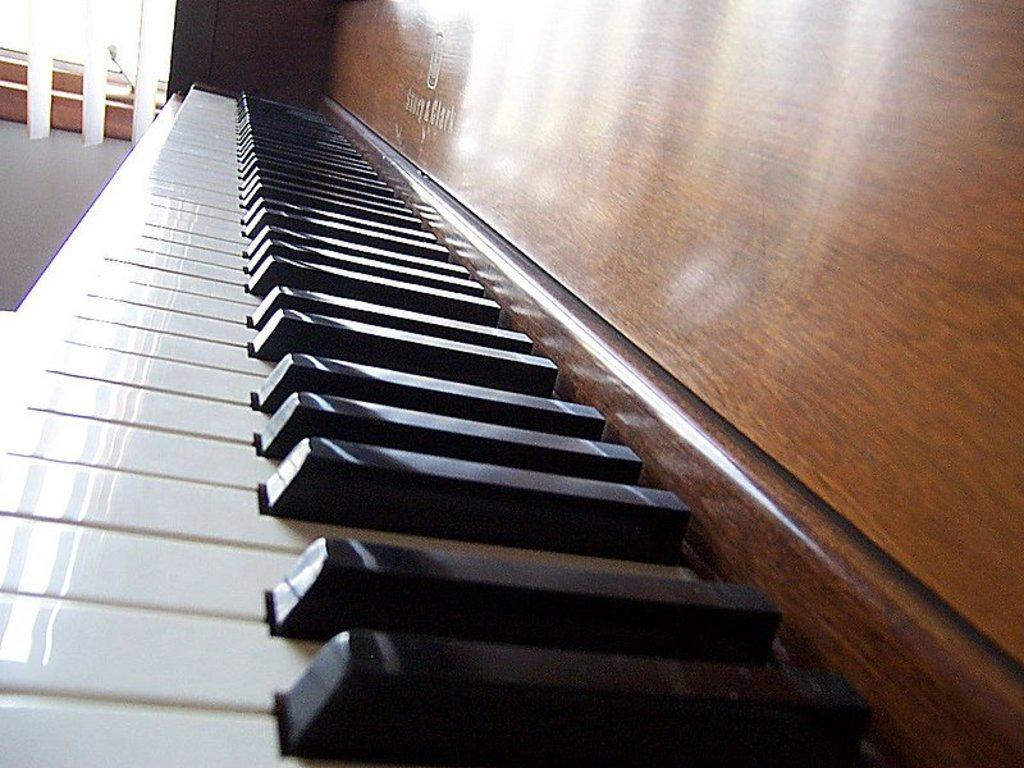What musical instrument is present in the image? There is a piano in the image. How is the piano connected to the wall? The piano is attached to a wooden wall. What type of oil is being used to clean the cork on the piano in the image? There is no cork or oil present in the image; it only features a piano attached to a wooden wall. 